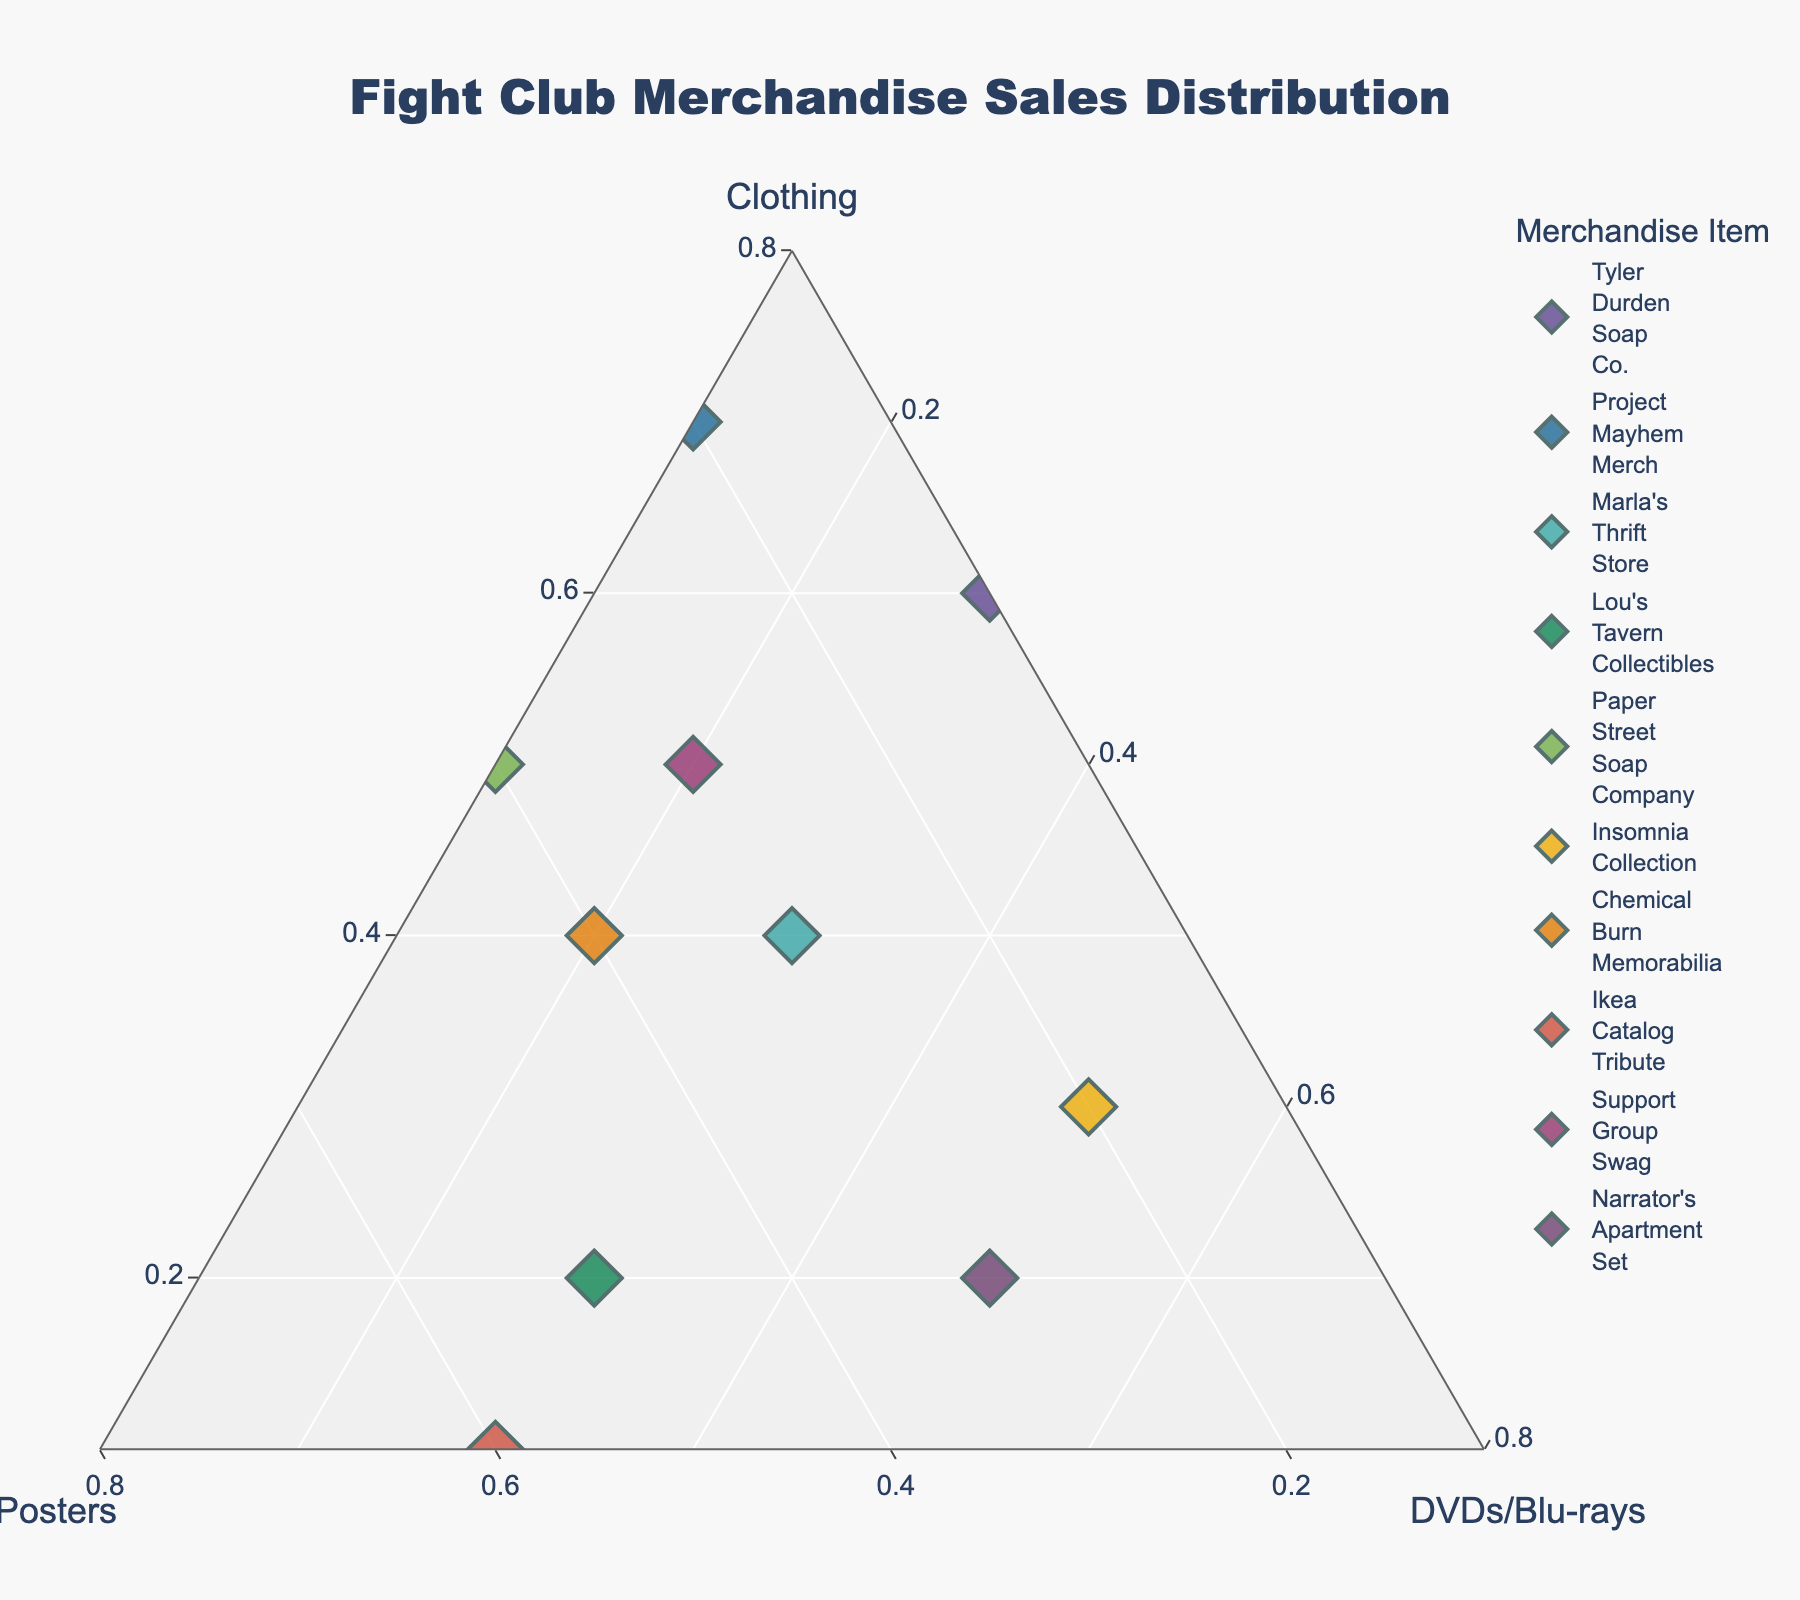What is the title of the ternary plot? The title can be found at the top of the plot.
Answer: Fight Club Merchandise Sales Distribution Which merchandise item has the highest proportion of clothing sales? Look for the point closest to the Clothing vertex.
Answer: Project Mayhem Merch What is the sum of the proportions for Posters and DVDs/Blu-rays for Marla's Thrift Store? Locate Marla's Thrift Store; Posters is 0.3 and DVDs/Blu-rays is 0.3. Sum them up: 0.3 + 0.3 = 0.6.
Answer: 0.6 How do the proportions of Clothing and Posters for Lou's Tavern Collectibles compare? Lou's Tavern Collectibles has 0.2 Clothing and 0.5 Posters. Posters proportion is greater than Clothing.
Answer: Posters > Clothing Which item has the closest proportion to equal parts of Clothing, Posters, and DVDs/Blu-rays? Look for the point nearest to the center of the plot where equal parts (0.33, 0.33, 0.33) would be.
Answer: Marla's Thrift Store What is the minimum value for any category (Clothing, Posters, or DVDs/Blu-rays) in the plot? Identify the smallest proportion displayed along the axes.
Answer: 0.1 How does the distribution of sales for Support Group Swag item compare to Chemical Burn Memorabilia? Support Group Swag (0.5, 0.3, 0.2) and Chemical Burn Memorabilia (0.4, 0.4, 0.2). Compare each category: Clothing is higher for Support Group Swag, Posters is higher for Chemical Burn Memorabilia, DVDs/Blu-rays are equal.
Answer: Support Group Swag has more Clothing, Chemical Burn Memorabilia has more Posters, DVDs/Blu-rays are equal Which item has the highest proportion of Posters? Look for the point closest to the Posters vertex.
Answer: Ikea Catalog Tribute What is the most common category with the highest proportion across all items? Observe the trends and commonalities in the proportions. Most points are closer to the Clothing vertex indicating the dominance of Clothing.
Answer: Clothing If you add the proportions of Posters and DVDs/Blu-rays for Paper Street Soap Company, does it exceed the proportion of Clothing? Paper Street Soap Company has Clothing (0.5), Posters (0.4), and DVDs/Blu-rays (0.1). Sum Posters and DVDs/Blu-rays: 0.4 + 0.1 = 0.5, which is equal to Clothing.
Answer: No 